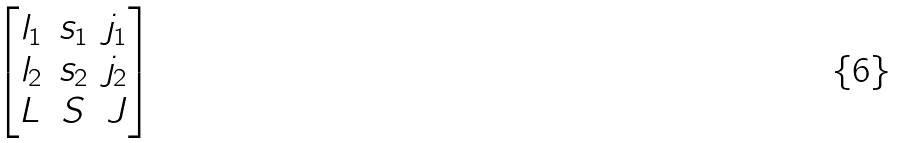Convert formula to latex. <formula><loc_0><loc_0><loc_500><loc_500>\begin{bmatrix} l _ { 1 } & s _ { 1 } & j _ { 1 } \\ l _ { 2 } & s _ { 2 } & j _ { 2 } \\ L & S & J \\ \end{bmatrix}</formula> 